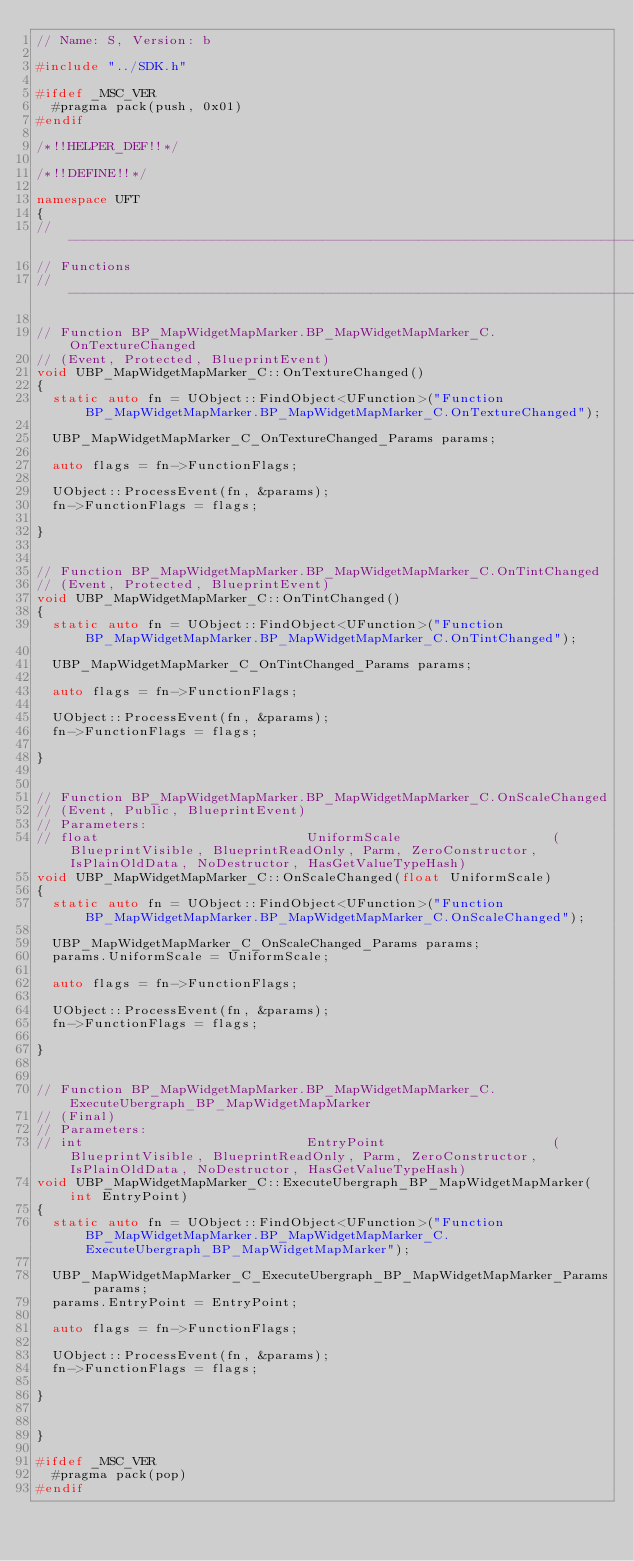<code> <loc_0><loc_0><loc_500><loc_500><_C++_>// Name: S, Version: b

#include "../SDK.h"

#ifdef _MSC_VER
	#pragma pack(push, 0x01)
#endif

/*!!HELPER_DEF!!*/

/*!!DEFINE!!*/

namespace UFT
{
//---------------------------------------------------------------------------
// Functions
//---------------------------------------------------------------------------

// Function BP_MapWidgetMapMarker.BP_MapWidgetMapMarker_C.OnTextureChanged
// (Event, Protected, BlueprintEvent)
void UBP_MapWidgetMapMarker_C::OnTextureChanged()
{
	static auto fn = UObject::FindObject<UFunction>("Function BP_MapWidgetMapMarker.BP_MapWidgetMapMarker_C.OnTextureChanged");

	UBP_MapWidgetMapMarker_C_OnTextureChanged_Params params;

	auto flags = fn->FunctionFlags;

	UObject::ProcessEvent(fn, &params);
	fn->FunctionFlags = flags;

}


// Function BP_MapWidgetMapMarker.BP_MapWidgetMapMarker_C.OnTintChanged
// (Event, Protected, BlueprintEvent)
void UBP_MapWidgetMapMarker_C::OnTintChanged()
{
	static auto fn = UObject::FindObject<UFunction>("Function BP_MapWidgetMapMarker.BP_MapWidgetMapMarker_C.OnTintChanged");

	UBP_MapWidgetMapMarker_C_OnTintChanged_Params params;

	auto flags = fn->FunctionFlags;

	UObject::ProcessEvent(fn, &params);
	fn->FunctionFlags = flags;

}


// Function BP_MapWidgetMapMarker.BP_MapWidgetMapMarker_C.OnScaleChanged
// (Event, Public, BlueprintEvent)
// Parameters:
// float                          UniformScale                   (BlueprintVisible, BlueprintReadOnly, Parm, ZeroConstructor, IsPlainOldData, NoDestructor, HasGetValueTypeHash)
void UBP_MapWidgetMapMarker_C::OnScaleChanged(float UniformScale)
{
	static auto fn = UObject::FindObject<UFunction>("Function BP_MapWidgetMapMarker.BP_MapWidgetMapMarker_C.OnScaleChanged");

	UBP_MapWidgetMapMarker_C_OnScaleChanged_Params params;
	params.UniformScale = UniformScale;

	auto flags = fn->FunctionFlags;

	UObject::ProcessEvent(fn, &params);
	fn->FunctionFlags = flags;

}


// Function BP_MapWidgetMapMarker.BP_MapWidgetMapMarker_C.ExecuteUbergraph_BP_MapWidgetMapMarker
// (Final)
// Parameters:
// int                            EntryPoint                     (BlueprintVisible, BlueprintReadOnly, Parm, ZeroConstructor, IsPlainOldData, NoDestructor, HasGetValueTypeHash)
void UBP_MapWidgetMapMarker_C::ExecuteUbergraph_BP_MapWidgetMapMarker(int EntryPoint)
{
	static auto fn = UObject::FindObject<UFunction>("Function BP_MapWidgetMapMarker.BP_MapWidgetMapMarker_C.ExecuteUbergraph_BP_MapWidgetMapMarker");

	UBP_MapWidgetMapMarker_C_ExecuteUbergraph_BP_MapWidgetMapMarker_Params params;
	params.EntryPoint = EntryPoint;

	auto flags = fn->FunctionFlags;

	UObject::ProcessEvent(fn, &params);
	fn->FunctionFlags = flags;

}


}

#ifdef _MSC_VER
	#pragma pack(pop)
#endif
</code> 